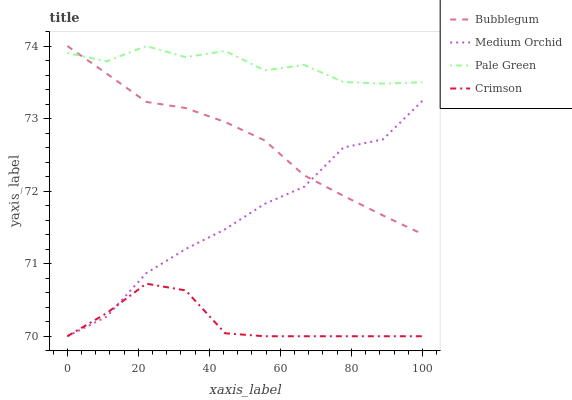Does Crimson have the minimum area under the curve?
Answer yes or no. Yes. Does Pale Green have the maximum area under the curve?
Answer yes or no. Yes. Does Medium Orchid have the minimum area under the curve?
Answer yes or no. No. Does Medium Orchid have the maximum area under the curve?
Answer yes or no. No. Is Bubblegum the smoothest?
Answer yes or no. Yes. Is Pale Green the roughest?
Answer yes or no. Yes. Is Medium Orchid the smoothest?
Answer yes or no. No. Is Medium Orchid the roughest?
Answer yes or no. No. Does Pale Green have the lowest value?
Answer yes or no. No. Does Bubblegum have the highest value?
Answer yes or no. Yes. Does Medium Orchid have the highest value?
Answer yes or no. No. Is Crimson less than Pale Green?
Answer yes or no. Yes. Is Pale Green greater than Medium Orchid?
Answer yes or no. Yes. Does Medium Orchid intersect Crimson?
Answer yes or no. Yes. Is Medium Orchid less than Crimson?
Answer yes or no. No. Is Medium Orchid greater than Crimson?
Answer yes or no. No. Does Crimson intersect Pale Green?
Answer yes or no. No. 